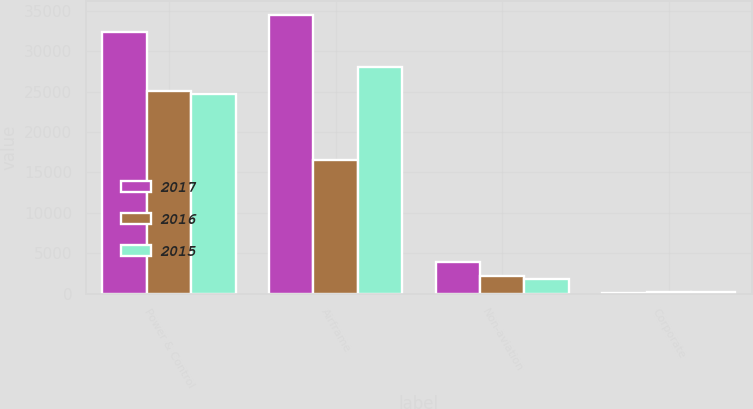Convert chart. <chart><loc_0><loc_0><loc_500><loc_500><stacked_bar_chart><ecel><fcel>Power & Control<fcel>Airframe<fcel>Non-aviation<fcel>Corporate<nl><fcel>2017<fcel>32424<fcel>34526<fcel>3981<fcel>82<nl><fcel>2016<fcel>25120<fcel>16498<fcel>2169<fcel>195<nl><fcel>2015<fcel>24664<fcel>28086<fcel>1889<fcel>232<nl></chart> 